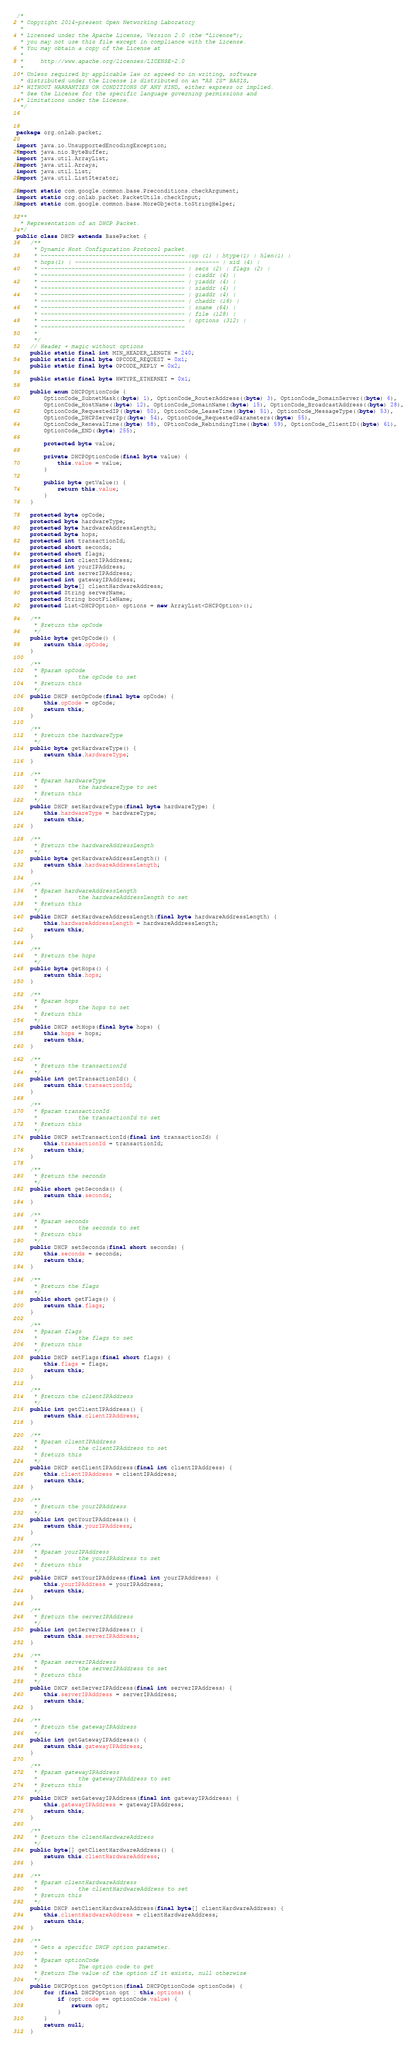Convert code to text. <code><loc_0><loc_0><loc_500><loc_500><_Java_>/*
 * Copyright 2014-present Open Networking Laboratory
 *
 * Licensed under the Apache License, Version 2.0 (the "License");
 * you may not use this file except in compliance with the License.
 * You may obtain a copy of the License at
 *
 *     http://www.apache.org/licenses/LICENSE-2.0
 *
 * Unless required by applicable law or agreed to in writing, software
 * distributed under the License is distributed on an "AS IS" BASIS,
 * WITHOUT WARRANTIES OR CONDITIONS OF ANY KIND, either express or implied.
 * See the License for the specific language governing permissions and
 * limitations under the License.
 */



package org.onlab.packet;

import java.io.UnsupportedEncodingException;
import java.nio.ByteBuffer;
import java.util.ArrayList;
import java.util.Arrays;
import java.util.List;
import java.util.ListIterator;

import static com.google.common.base.Preconditions.checkArgument;
import static org.onlab.packet.PacketUtils.checkInput;
import static com.google.common.base.MoreObjects.toStringHelper;

/**
 * Representation of an DHCP Packet.
 */
public class DHCP extends BasePacket {
    /**
     * Dynamic Host Configuration Protocol packet.
     * ------------------------------------------ |op (1) | htype(1) | hlen(1) |
     * hops(1) | ------------------------------------------ | xid (4) |
     * ------------------------------------------ | secs (2) | flags (2) |
     * ------------------------------------------ | ciaddr (4) |
     * ------------------------------------------ | yiaddr (4) |
     * ------------------------------------------ | siaddr (4) |
     * ------------------------------------------ | giaddr (4) |
     * ------------------------------------------ | chaddr (16) |
     * ------------------------------------------ | sname (64) |
     * ------------------------------------------ | file (128) |
     * ------------------------------------------ | options (312) |
     * ------------------------------------------
     *
     */
    // Header + magic without options
    public static final int MIN_HEADER_LENGTH = 240;
    public static final byte OPCODE_REQUEST = 0x1;
    public static final byte OPCODE_REPLY = 0x2;

    public static final byte HWTYPE_ETHERNET = 0x1;

    public enum DHCPOptionCode {
        OptionCode_SubnetMask((byte) 1), OptionCode_RouterAddress((byte) 3), OptionCode_DomainServer((byte) 6),
        OptionCode_HostName((byte) 12), OptionCode_DomainName((byte) 15), OptionCode_BroadcastAddress((byte) 28),
        OptionCode_RequestedIP((byte) 50), OptionCode_LeaseTime((byte) 51), OptionCode_MessageType((byte) 53),
        OptionCode_DHCPServerIp((byte) 54), OptionCode_RequestedParameters((byte) 55),
        OptionCode_RenewalTime((byte) 58), OPtionCode_RebindingTime((byte) 59), OptionCode_ClientID((byte) 61),
        OptionCode_END((byte) 255);

        protected byte value;

        private DHCPOptionCode(final byte value) {
            this.value = value;
        }

        public byte getValue() {
            return this.value;
        }
    }

    protected byte opCode;
    protected byte hardwareType;
    protected byte hardwareAddressLength;
    protected byte hops;
    protected int transactionId;
    protected short seconds;
    protected short flags;
    protected int clientIPAddress;
    protected int yourIPAddress;
    protected int serverIPAddress;
    protected int gatewayIPAddress;
    protected byte[] clientHardwareAddress;
    protected String serverName;
    protected String bootFileName;
    protected List<DHCPOption> options = new ArrayList<DHCPOption>();

    /**
     * @return the opCode
     */
    public byte getOpCode() {
        return this.opCode;
    }

    /**
     * @param opCode
     *            the opCode to set
     * @return this
     */
    public DHCP setOpCode(final byte opCode) {
        this.opCode = opCode;
        return this;
    }

    /**
     * @return the hardwareType
     */
    public byte getHardwareType() {
        return this.hardwareType;
    }

    /**
     * @param hardwareType
     *            the hardwareType to set
     * @return this
     */
    public DHCP setHardwareType(final byte hardwareType) {
        this.hardwareType = hardwareType;
        return this;
    }

    /**
     * @return the hardwareAddressLength
     */
    public byte getHardwareAddressLength() {
        return this.hardwareAddressLength;
    }

    /**
     * @param hardwareAddressLength
     *            the hardwareAddressLength to set
     * @return this
     */
    public DHCP setHardwareAddressLength(final byte hardwareAddressLength) {
        this.hardwareAddressLength = hardwareAddressLength;
        return this;
    }

    /**
     * @return the hops
     */
    public byte getHops() {
        return this.hops;
    }

    /**
     * @param hops
     *            the hops to set
     * @return this
     */
    public DHCP setHops(final byte hops) {
        this.hops = hops;
        return this;
    }

    /**
     * @return the transactionId
     */
    public int getTransactionId() {
        return this.transactionId;
    }

    /**
     * @param transactionId
     *            the transactionId to set
     * @return this
     */
    public DHCP setTransactionId(final int transactionId) {
        this.transactionId = transactionId;
        return this;
    }

    /**
     * @return the seconds
     */
    public short getSeconds() {
        return this.seconds;
    }

    /**
     * @param seconds
     *            the seconds to set
     * @return this
     */
    public DHCP setSeconds(final short seconds) {
        this.seconds = seconds;
        return this;
    }

    /**
     * @return the flags
     */
    public short getFlags() {
        return this.flags;
    }

    /**
     * @param flags
     *            the flags to set
     * @return this
     */
    public DHCP setFlags(final short flags) {
        this.flags = flags;
        return this;
    }

    /**
     * @return the clientIPAddress
     */
    public int getClientIPAddress() {
        return this.clientIPAddress;
    }

    /**
     * @param clientIPAddress
     *            the clientIPAddress to set
     * @return this
     */
    public DHCP setClientIPAddress(final int clientIPAddress) {
        this.clientIPAddress = clientIPAddress;
        return this;
    }

    /**
     * @return the yourIPAddress
     */
    public int getYourIPAddress() {
        return this.yourIPAddress;
    }

    /**
     * @param yourIPAddress
     *            the yourIPAddress to set
     * @return this
     */
    public DHCP setYourIPAddress(final int yourIPAddress) {
        this.yourIPAddress = yourIPAddress;
        return this;
    }

    /**
     * @return the serverIPAddress
     */
    public int getServerIPAddress() {
        return this.serverIPAddress;
    }

    /**
     * @param serverIPAddress
     *            the serverIPAddress to set
     * @return this
     */
    public DHCP setServerIPAddress(final int serverIPAddress) {
        this.serverIPAddress = serverIPAddress;
        return this;
    }

    /**
     * @return the gatewayIPAddress
     */
    public int getGatewayIPAddress() {
        return this.gatewayIPAddress;
    }

    /**
     * @param gatewayIPAddress
     *            the gatewayIPAddress to set
     * @return this
     */
    public DHCP setGatewayIPAddress(final int gatewayIPAddress) {
        this.gatewayIPAddress = gatewayIPAddress;
        return this;
    }

    /**
     * @return the clientHardwareAddress
     */
    public byte[] getClientHardwareAddress() {
        return this.clientHardwareAddress;
    }

    /**
     * @param clientHardwareAddress
     *            the clientHardwareAddress to set
     * @return this
     */
    public DHCP setClientHardwareAddress(final byte[] clientHardwareAddress) {
        this.clientHardwareAddress = clientHardwareAddress;
        return this;
    }

    /**
     * Gets a specific DHCP option parameter.
     *
     * @param optionCode
     *            The option code to get
     * @return The value of the option if it exists, null otherwise
     */
    public DHCPOption getOption(final DHCPOptionCode optionCode) {
        for (final DHCPOption opt : this.options) {
            if (opt.code == optionCode.value) {
                return opt;
            }
        }
        return null;
    }
</code> 